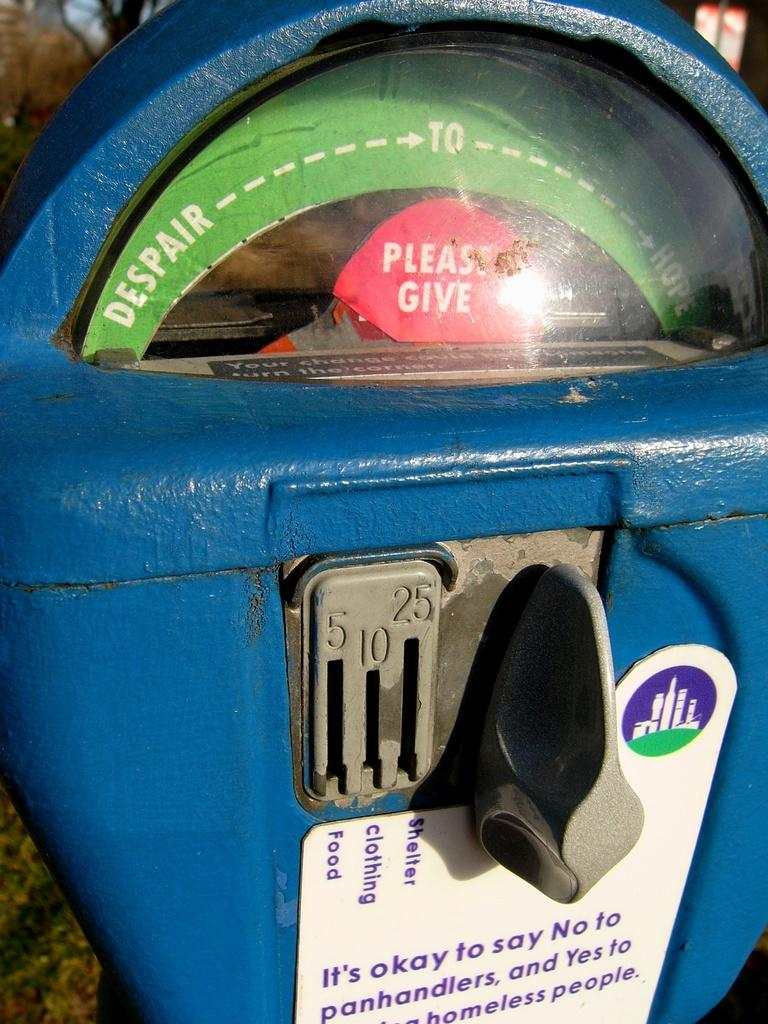Provide a one-sentence caption for the provided image. A parking meter has been repurposed for charity aith a pop up that says please give. 